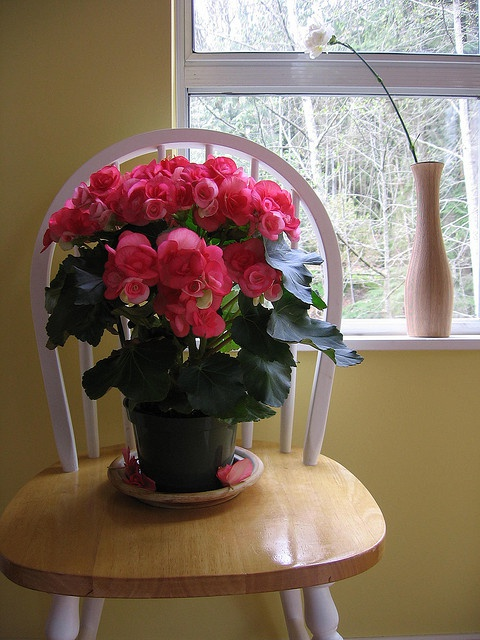Describe the objects in this image and their specific colors. I can see potted plant in black, maroon, brown, and gray tones, vase in black, darkgreen, and gray tones, and vase in black, gray, brown, and darkgray tones in this image. 